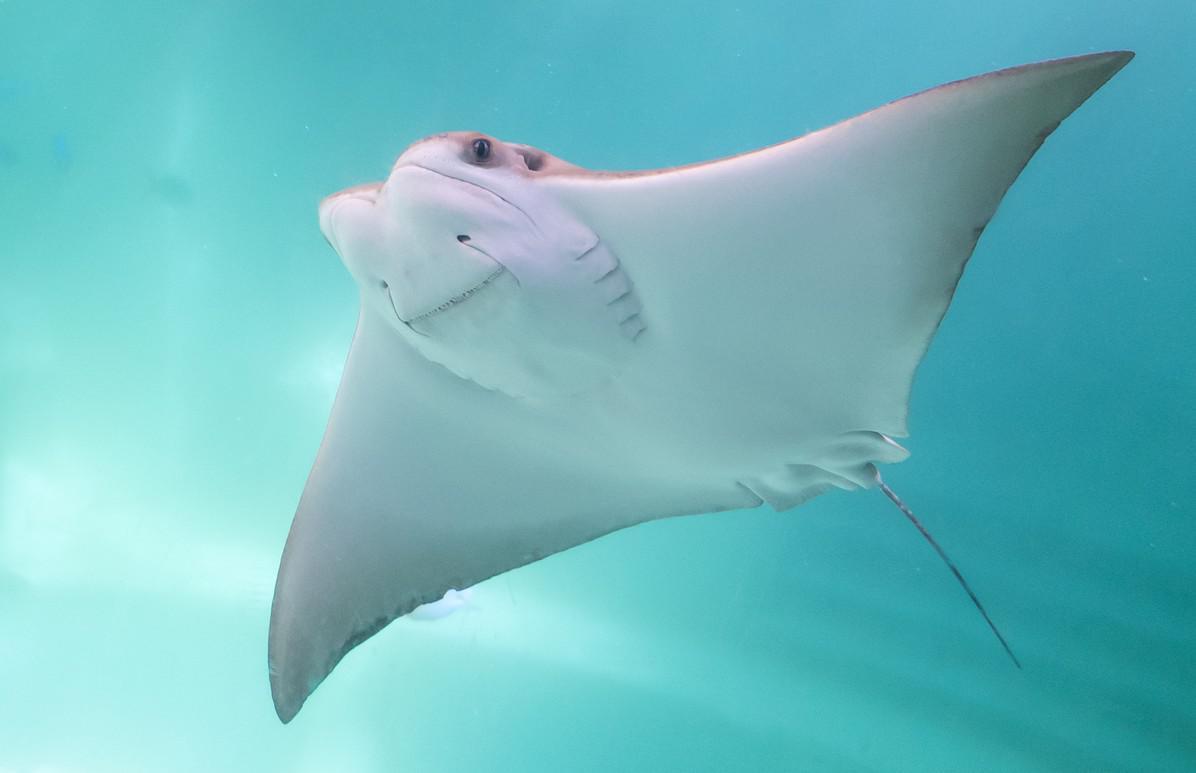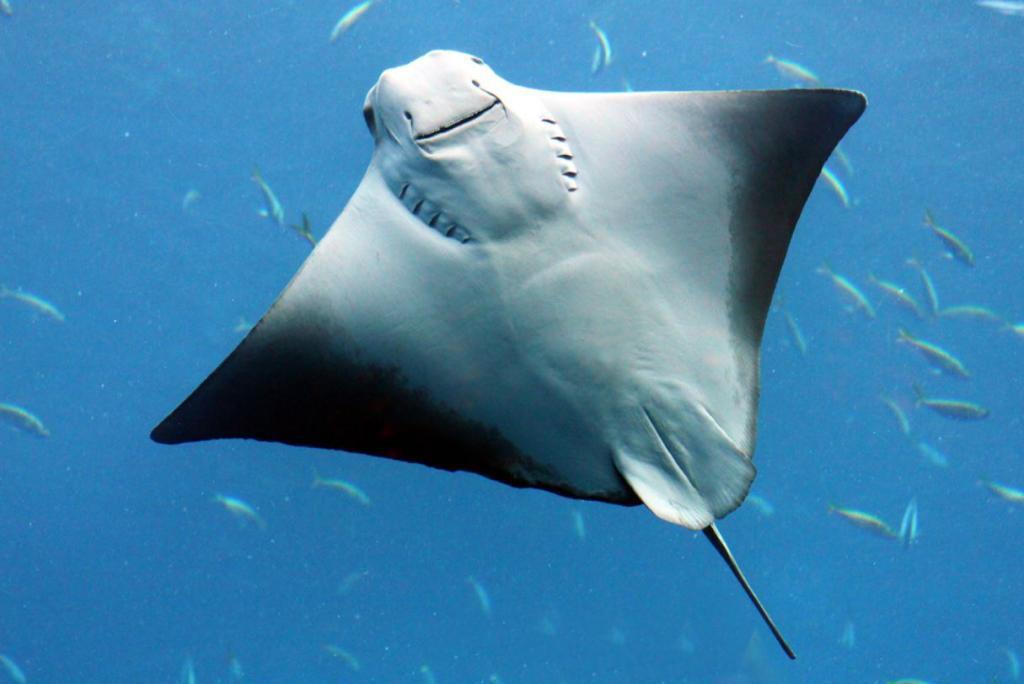The first image is the image on the left, the second image is the image on the right. Examine the images to the left and right. Is the description "The top of the ray in the image on the left is visible." accurate? Answer yes or no. No. The first image is the image on the left, the second image is the image on the right. Analyze the images presented: Is the assertion "Right image shows the underbelly of a stingray, and the left shows a top-view of a stingray near the ocean bottom." valid? Answer yes or no. No. 